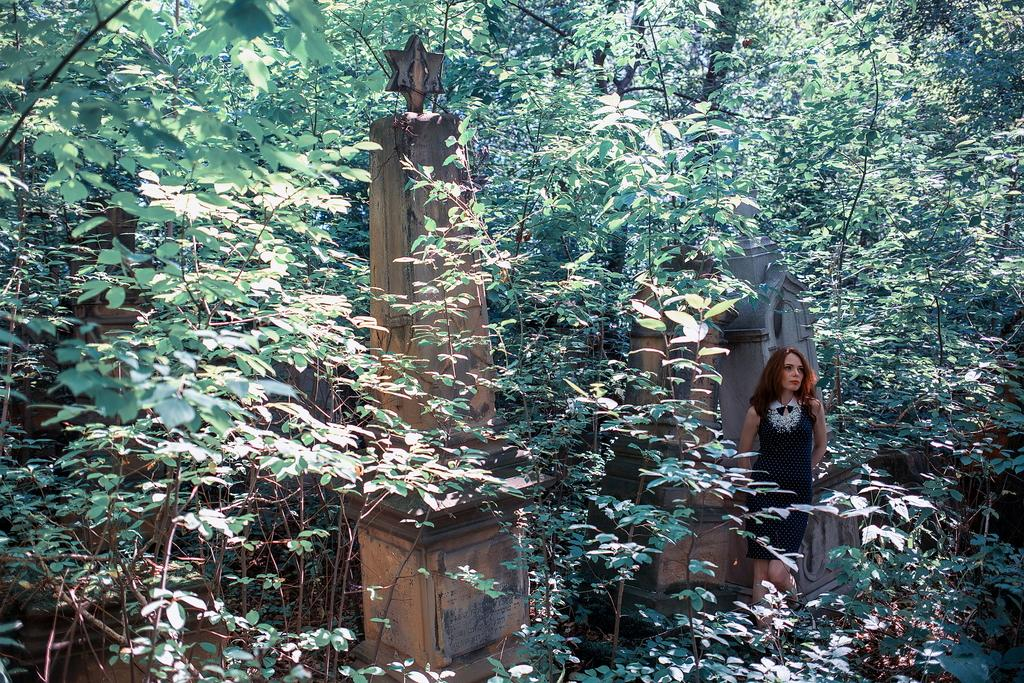What type of environment is shown in the image? The image depicts a forest area. What can be found in the forest area? The forest area is full of trees. Are there any other objects or features in the forest area? Yes, there are sculptured stones in the forest area. Can you describe the woman in the image? The woman is standing near the sculptured stones, and she is wearing a black dress. What type of roof can be seen on the jail in the image? There is no jail or roof present in the image; it depicts a forest area with trees, sculptured stones, and a woman in a black dress. 